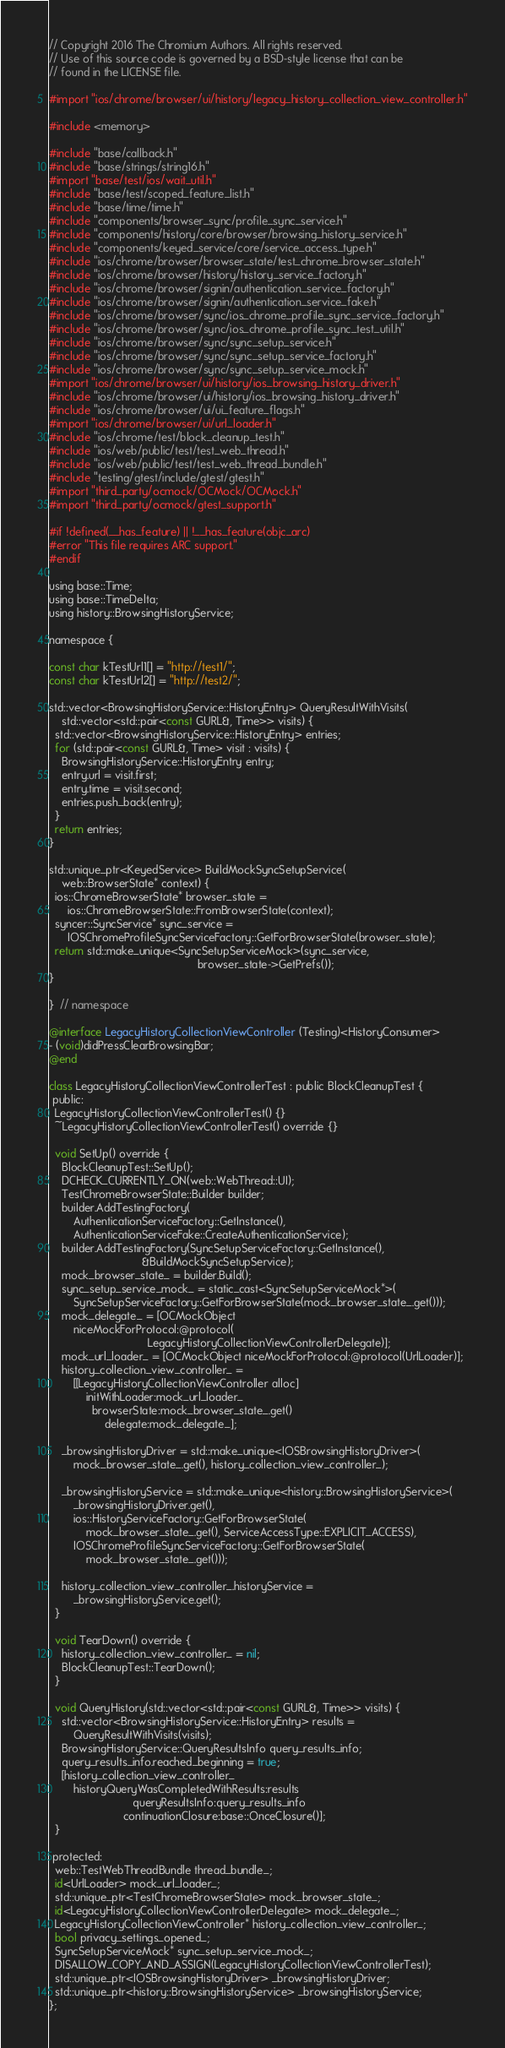<code> <loc_0><loc_0><loc_500><loc_500><_ObjectiveC_>// Copyright 2016 The Chromium Authors. All rights reserved.
// Use of this source code is governed by a BSD-style license that can be
// found in the LICENSE file.

#import "ios/chrome/browser/ui/history/legacy_history_collection_view_controller.h"

#include <memory>

#include "base/callback.h"
#include "base/strings/string16.h"
#import "base/test/ios/wait_util.h"
#include "base/test/scoped_feature_list.h"
#include "base/time/time.h"
#include "components/browser_sync/profile_sync_service.h"
#include "components/history/core/browser/browsing_history_service.h"
#include "components/keyed_service/core/service_access_type.h"
#include "ios/chrome/browser/browser_state/test_chrome_browser_state.h"
#include "ios/chrome/browser/history/history_service_factory.h"
#include "ios/chrome/browser/signin/authentication_service_factory.h"
#include "ios/chrome/browser/signin/authentication_service_fake.h"
#include "ios/chrome/browser/sync/ios_chrome_profile_sync_service_factory.h"
#include "ios/chrome/browser/sync/ios_chrome_profile_sync_test_util.h"
#include "ios/chrome/browser/sync/sync_setup_service.h"
#include "ios/chrome/browser/sync/sync_setup_service_factory.h"
#include "ios/chrome/browser/sync/sync_setup_service_mock.h"
#import "ios/chrome/browser/ui/history/ios_browsing_history_driver.h"
#include "ios/chrome/browser/ui/history/ios_browsing_history_driver.h"
#include "ios/chrome/browser/ui/ui_feature_flags.h"
#import "ios/chrome/browser/ui/url_loader.h"
#include "ios/chrome/test/block_cleanup_test.h"
#include "ios/web/public/test/test_web_thread.h"
#include "ios/web/public/test/test_web_thread_bundle.h"
#include "testing/gtest/include/gtest/gtest.h"
#import "third_party/ocmock/OCMock/OCMock.h"
#import "third_party/ocmock/gtest_support.h"

#if !defined(__has_feature) || !__has_feature(objc_arc)
#error "This file requires ARC support."
#endif

using base::Time;
using base::TimeDelta;
using history::BrowsingHistoryService;

namespace {

const char kTestUrl1[] = "http://test1/";
const char kTestUrl2[] = "http://test2/";

std::vector<BrowsingHistoryService::HistoryEntry> QueryResultWithVisits(
    std::vector<std::pair<const GURL&, Time>> visits) {
  std::vector<BrowsingHistoryService::HistoryEntry> entries;
  for (std::pair<const GURL&, Time> visit : visits) {
    BrowsingHistoryService::HistoryEntry entry;
    entry.url = visit.first;
    entry.time = visit.second;
    entries.push_back(entry);
  }
  return entries;
}

std::unique_ptr<KeyedService> BuildMockSyncSetupService(
    web::BrowserState* context) {
  ios::ChromeBrowserState* browser_state =
      ios::ChromeBrowserState::FromBrowserState(context);
  syncer::SyncService* sync_service =
      IOSChromeProfileSyncServiceFactory::GetForBrowserState(browser_state);
  return std::make_unique<SyncSetupServiceMock>(sync_service,
                                                browser_state->GetPrefs());
}

}  // namespace

@interface LegacyHistoryCollectionViewController (Testing)<HistoryConsumer>
- (void)didPressClearBrowsingBar;
@end

class LegacyHistoryCollectionViewControllerTest : public BlockCleanupTest {
 public:
  LegacyHistoryCollectionViewControllerTest() {}
  ~LegacyHistoryCollectionViewControllerTest() override {}

  void SetUp() override {
    BlockCleanupTest::SetUp();
    DCHECK_CURRENTLY_ON(web::WebThread::UI);
    TestChromeBrowserState::Builder builder;
    builder.AddTestingFactory(
        AuthenticationServiceFactory::GetInstance(),
        AuthenticationServiceFake::CreateAuthenticationService);
    builder.AddTestingFactory(SyncSetupServiceFactory::GetInstance(),
                              &BuildMockSyncSetupService);
    mock_browser_state_ = builder.Build();
    sync_setup_service_mock_ = static_cast<SyncSetupServiceMock*>(
        SyncSetupServiceFactory::GetForBrowserState(mock_browser_state_.get()));
    mock_delegate_ = [OCMockObject
        niceMockForProtocol:@protocol(
                                LegacyHistoryCollectionViewControllerDelegate)];
    mock_url_loader_ = [OCMockObject niceMockForProtocol:@protocol(UrlLoader)];
    history_collection_view_controller_ =
        [[LegacyHistoryCollectionViewController alloc]
            initWithLoader:mock_url_loader_
              browserState:mock_browser_state_.get()
                  delegate:mock_delegate_];

    _browsingHistoryDriver = std::make_unique<IOSBrowsingHistoryDriver>(
        mock_browser_state_.get(), history_collection_view_controller_);

    _browsingHistoryService = std::make_unique<history::BrowsingHistoryService>(
        _browsingHistoryDriver.get(),
        ios::HistoryServiceFactory::GetForBrowserState(
            mock_browser_state_.get(), ServiceAccessType::EXPLICIT_ACCESS),
        IOSChromeProfileSyncServiceFactory::GetForBrowserState(
            mock_browser_state_.get()));

    history_collection_view_controller_.historyService =
        _browsingHistoryService.get();
  }

  void TearDown() override {
    history_collection_view_controller_ = nil;
    BlockCleanupTest::TearDown();
  }

  void QueryHistory(std::vector<std::pair<const GURL&, Time>> visits) {
    std::vector<BrowsingHistoryService::HistoryEntry> results =
        QueryResultWithVisits(visits);
    BrowsingHistoryService::QueryResultsInfo query_results_info;
    query_results_info.reached_beginning = true;
    [history_collection_view_controller_
        historyQueryWasCompletedWithResults:results
                           queryResultsInfo:query_results_info
                        continuationClosure:base::OnceClosure()];
  }

 protected:
  web::TestWebThreadBundle thread_bundle_;
  id<UrlLoader> mock_url_loader_;
  std::unique_ptr<TestChromeBrowserState> mock_browser_state_;
  id<LegacyHistoryCollectionViewControllerDelegate> mock_delegate_;
  LegacyHistoryCollectionViewController* history_collection_view_controller_;
  bool privacy_settings_opened_;
  SyncSetupServiceMock* sync_setup_service_mock_;
  DISALLOW_COPY_AND_ASSIGN(LegacyHistoryCollectionViewControllerTest);
  std::unique_ptr<IOSBrowsingHistoryDriver> _browsingHistoryDriver;
  std::unique_ptr<history::BrowsingHistoryService> _browsingHistoryService;
};
</code> 